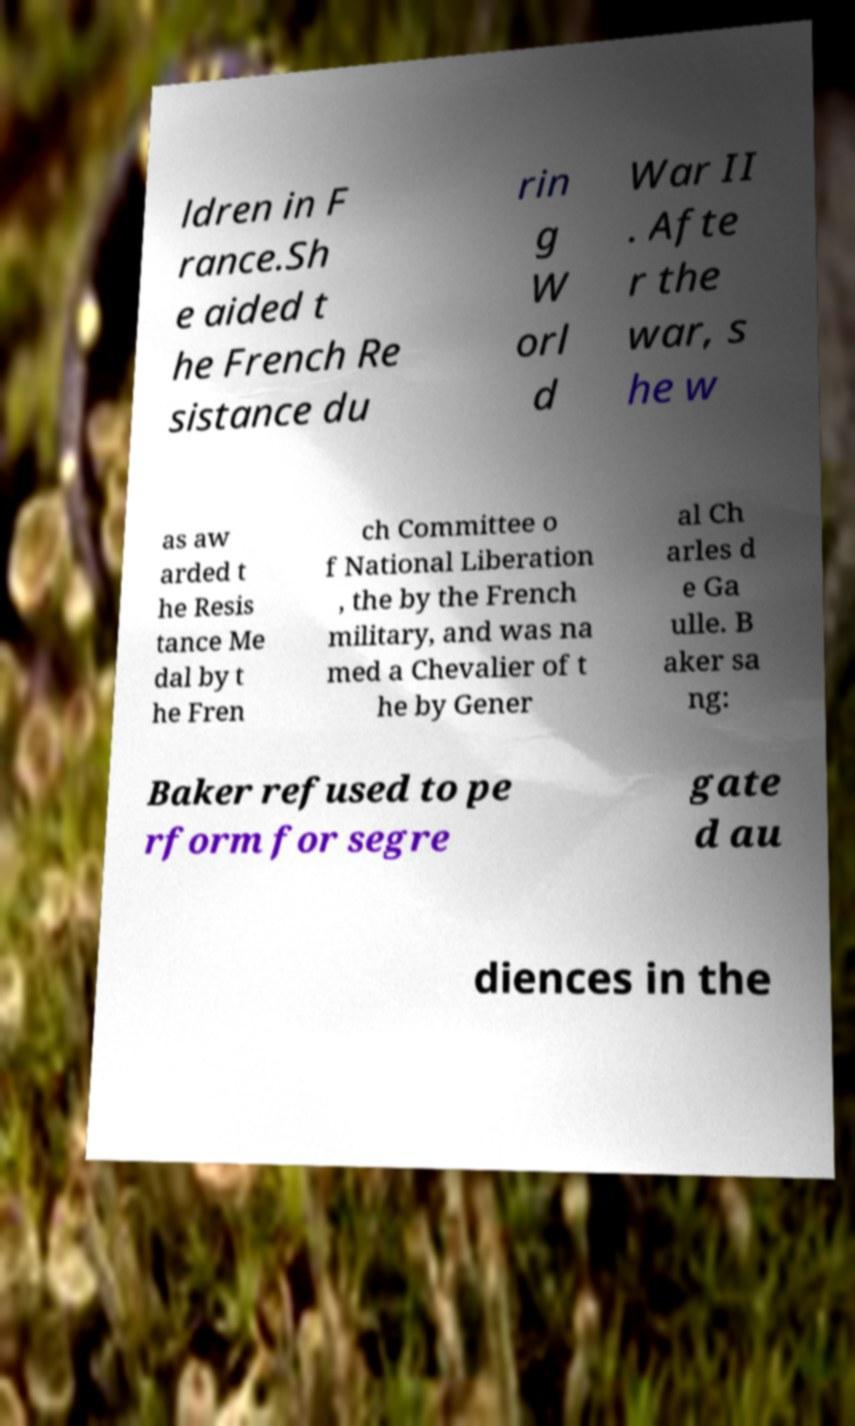For documentation purposes, I need the text within this image transcribed. Could you provide that? ldren in F rance.Sh e aided t he French Re sistance du rin g W orl d War II . Afte r the war, s he w as aw arded t he Resis tance Me dal by t he Fren ch Committee o f National Liberation , the by the French military, and was na med a Chevalier of t he by Gener al Ch arles d e Ga ulle. B aker sa ng: Baker refused to pe rform for segre gate d au diences in the 